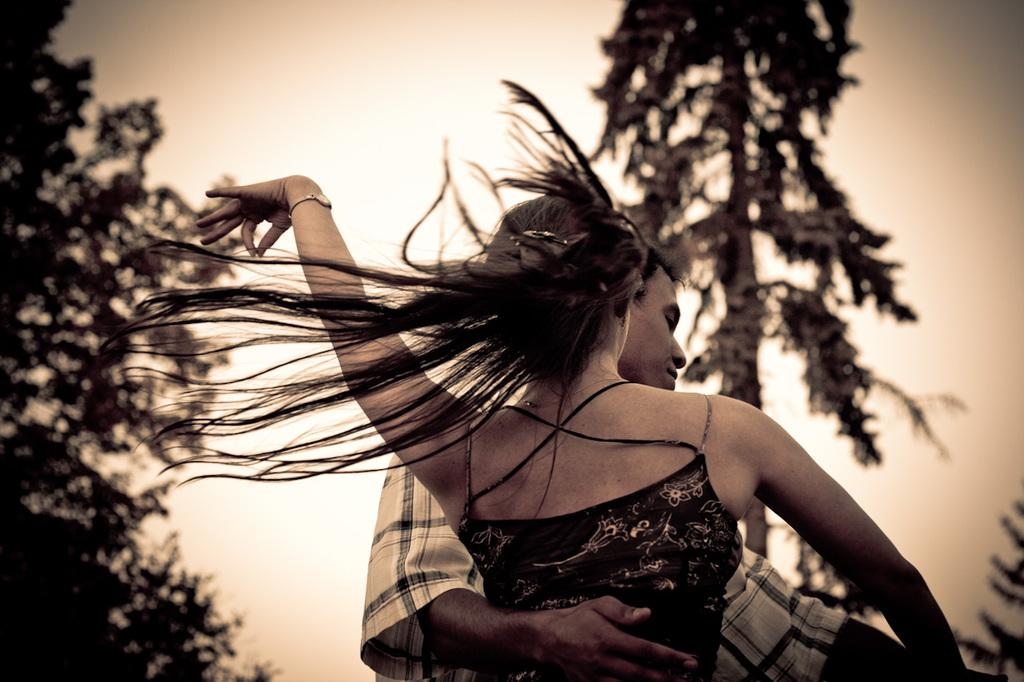How many people are in the image? There are two persons in the image. What can be seen in the background of the image? There are trees and the sky visible in the background of the image. What type of rail can be seen in the middle of the image? There is no rail present in the image; it features two persons and a background with trees and the sky. What arithmetic problem is being solved by the persons in the image? There is no indication in the image that the persons are solving an arithmetic problem. 